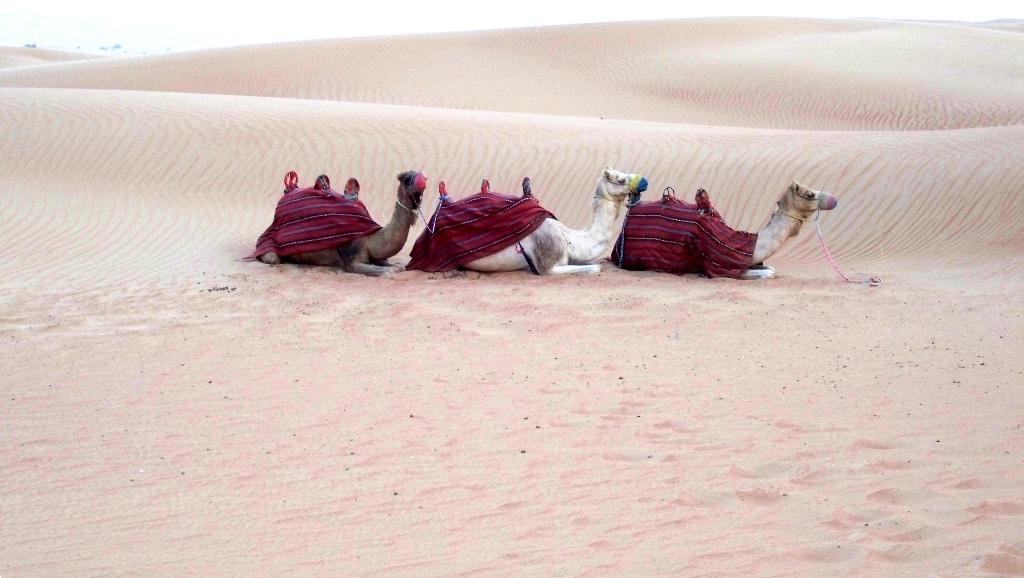Please provide a concise description of this image. Here in this picture we can see three camels present in a desert, as we can see sand covered all over there and on their back we can see a cloth and a seat present. 